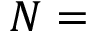Convert formula to latex. <formula><loc_0><loc_0><loc_500><loc_500>N =</formula> 